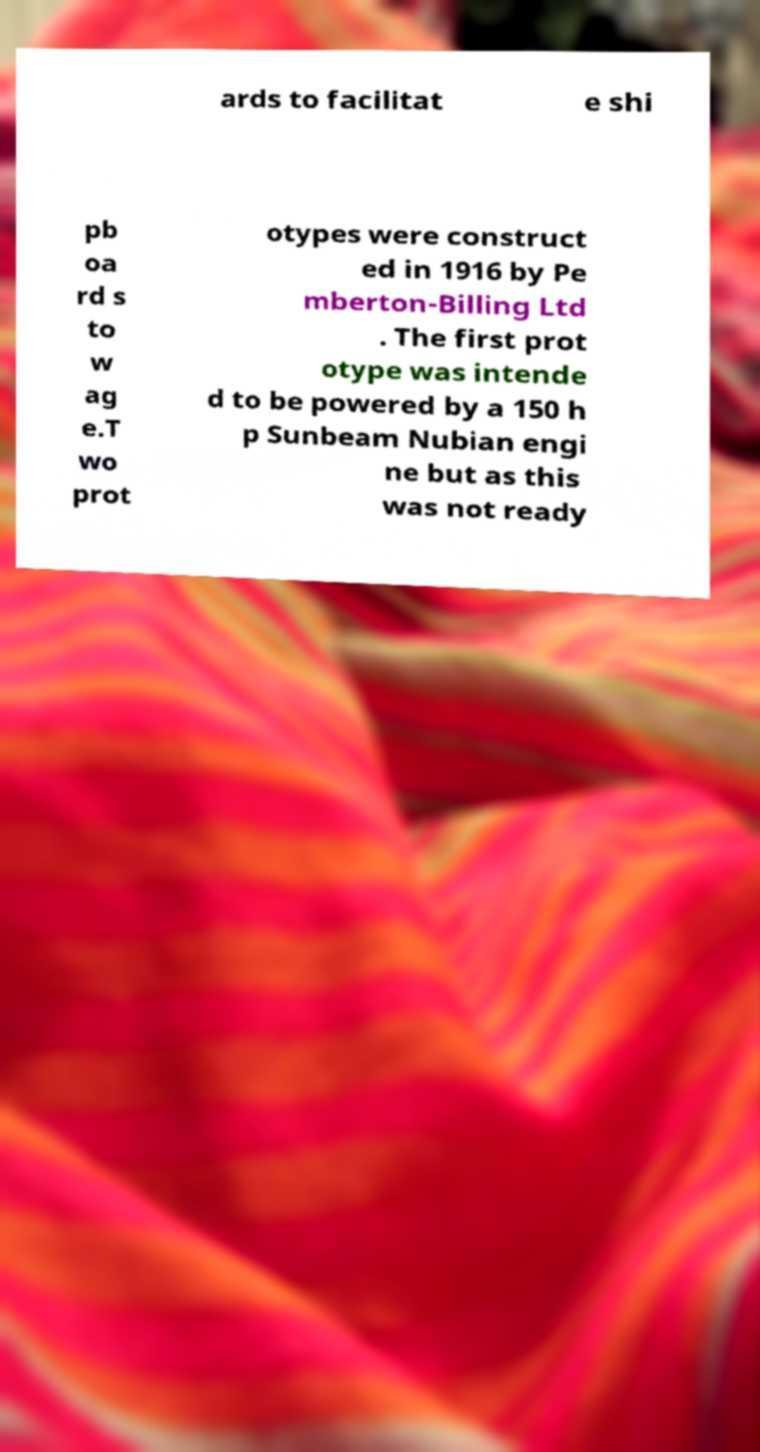Could you assist in decoding the text presented in this image and type it out clearly? ards to facilitat e shi pb oa rd s to w ag e.T wo prot otypes were construct ed in 1916 by Pe mberton-Billing Ltd . The first prot otype was intende d to be powered by a 150 h p Sunbeam Nubian engi ne but as this was not ready 